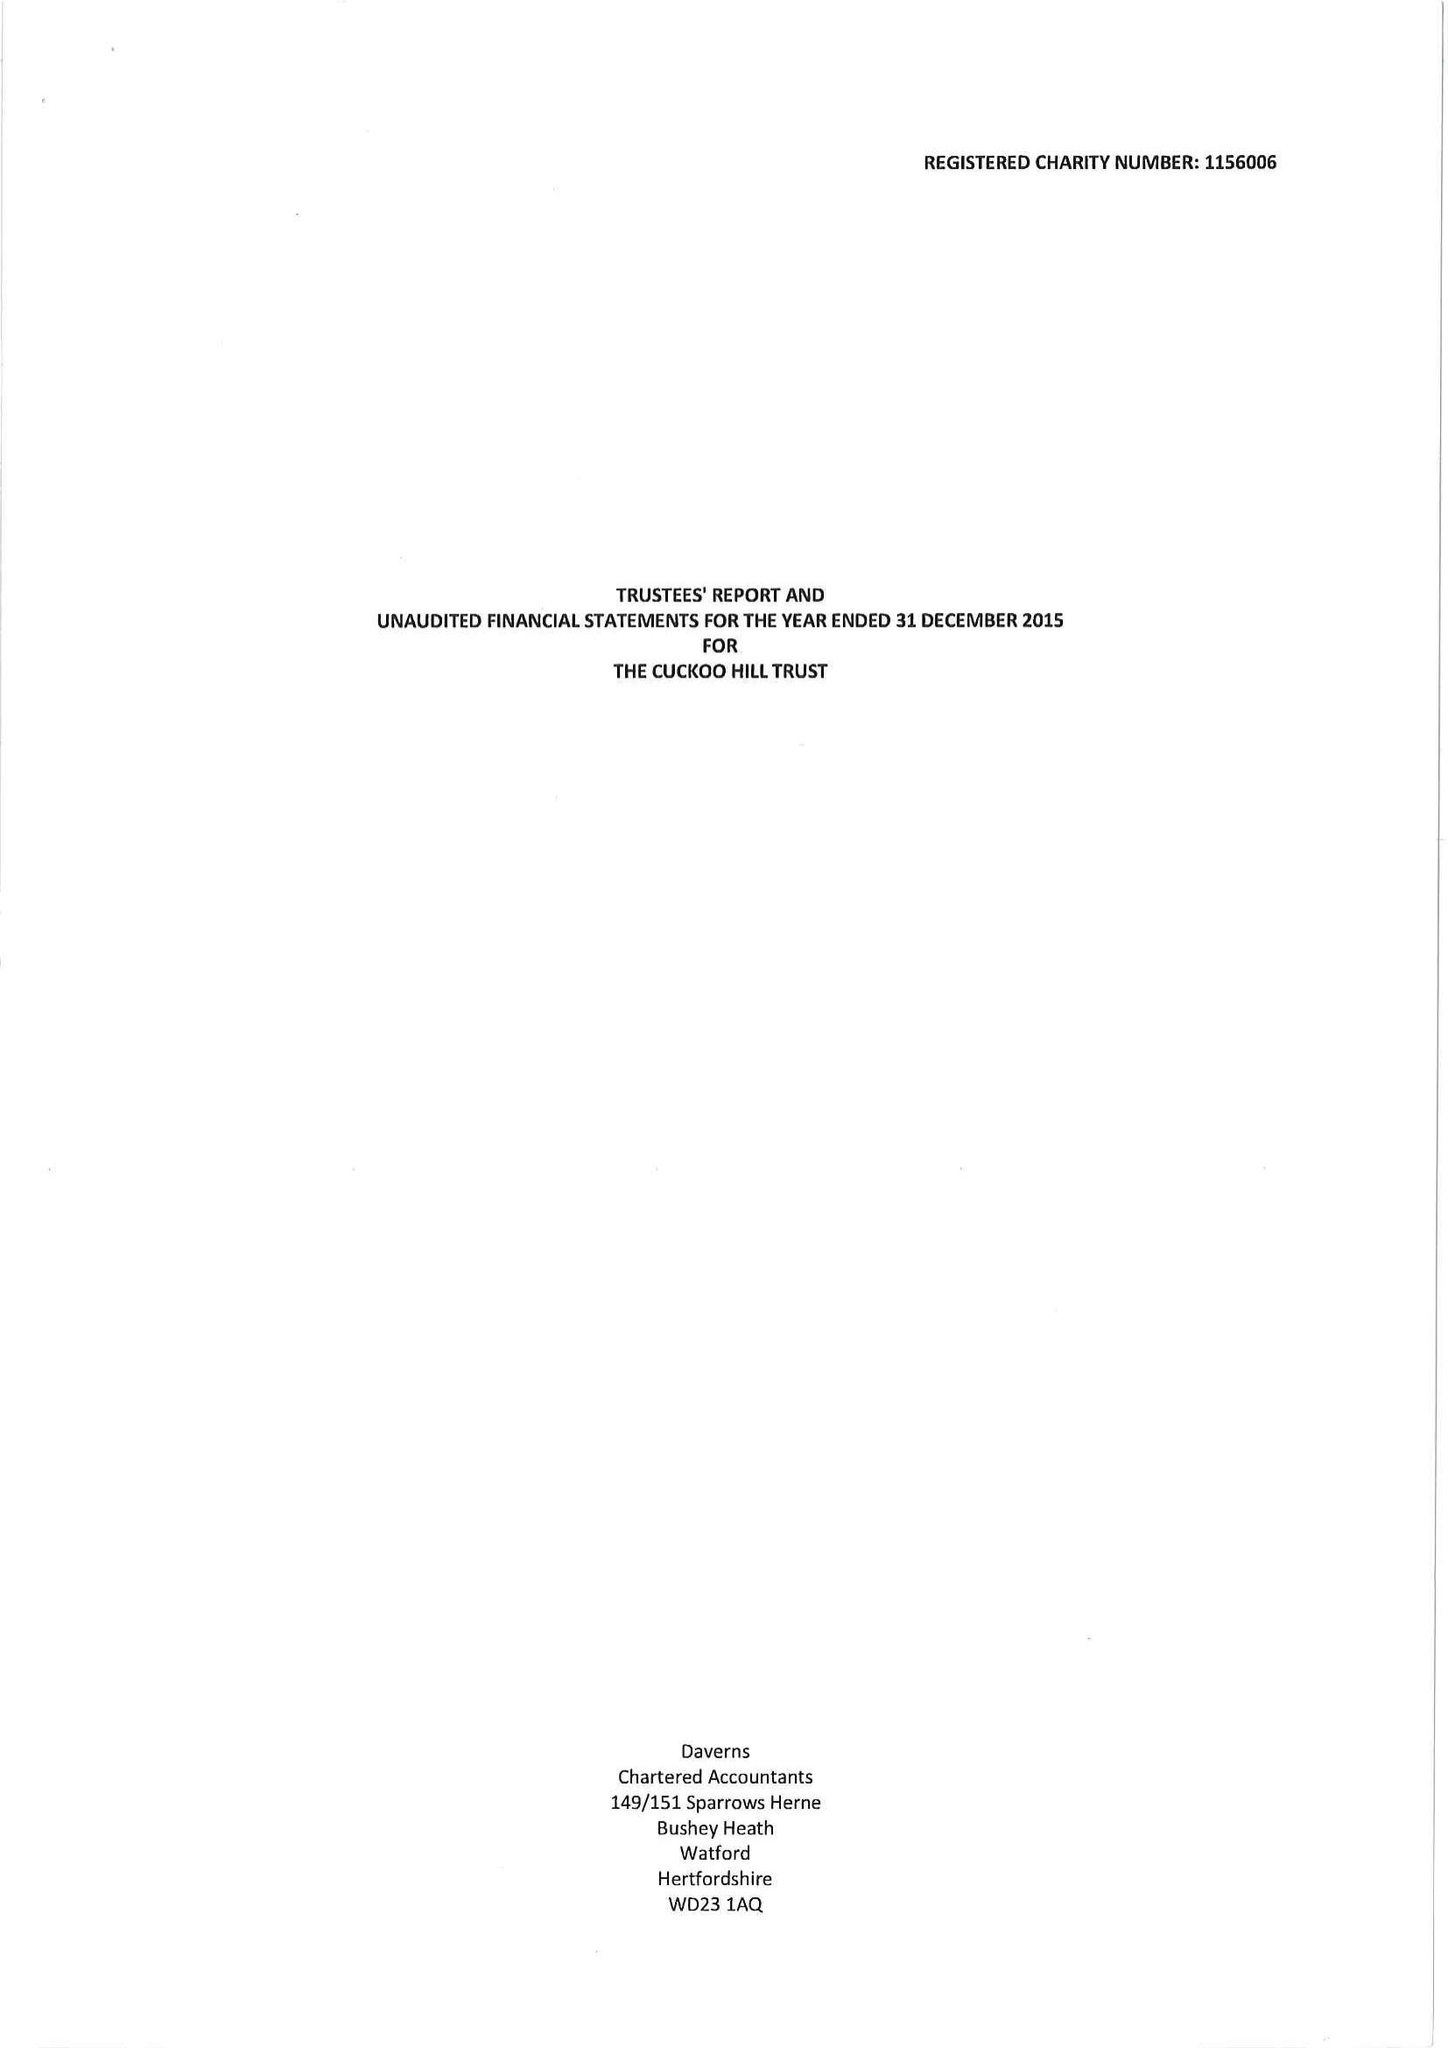What is the value for the charity_name?
Answer the question using a single word or phrase. The Cuckoo Hill Trust 